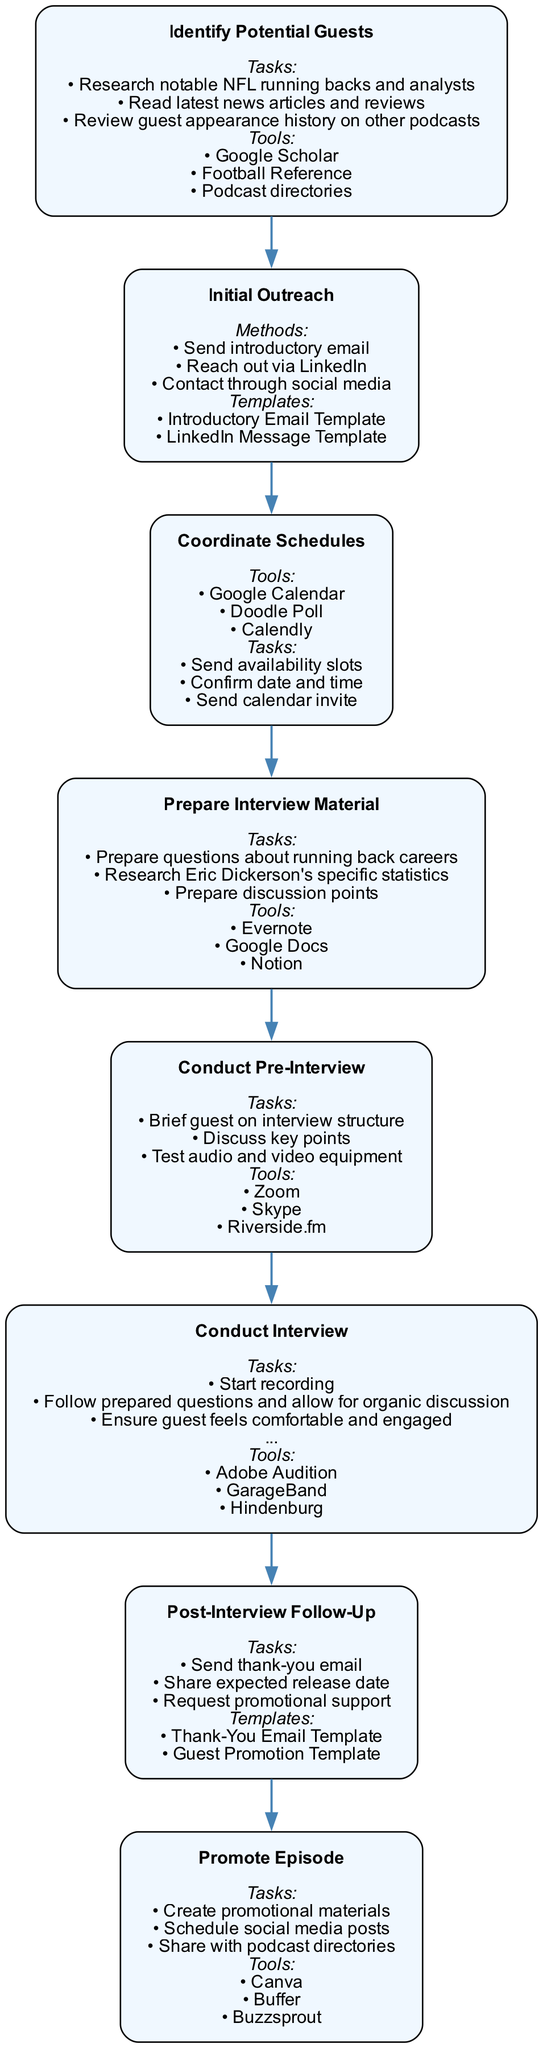What is the first step in the diagram? The diagram starts with the step labeled "Identify Potential Guests," which is the initial stage of the collaboration and scheduling process.
Answer: Identify Potential Guests How many steps are there in total? The diagram consists of eight distinct steps, each representing different parts of the process for collaborating with guest speakers and scheduling interviews.
Answer: Eight What tool is used to coordinate schedules? The diagram lists "Google Calendar," "Doodle Poll," and "Calendly" as tools for coordinating schedules, indicating a variety of options available for scheduling interviews.
Answer: Google Calendar Which step follows "Conduct Pre-Interview"? The step that comes after "Conduct Pre-Interview" in the flow is "Conduct Interview," which implies that after preparing, the actual interview is conducted.
Answer: Conduct Interview What is a task involved in the "Post-Interview Follow-Up" step? A task included in the "Post-Interview Follow-Up" is "Send thank-you email," indicating an essential part of maintaining relationships with guests after the recording process.
Answer: Send thank-you email Which two methods are used for initial outreach? The initial outreach can be done through "Send introductory email" and "Reach out via LinkedIn," showcasing methods of contacting potential guests.
Answer: Send introductory email What are the tools used in "Prepare Interview Material"? In the "Prepare Interview Material" step, the tools mentioned are "Evernote," "Google Docs," and "Notion," emphasizing the digital tools available for preparing content.
Answer: Evernote Which step is focused on promotion? The "Promote Episode" step specifically focuses on promoting the completed podcast episode, indicating its importance in reaching the audience.
Answer: Promote Episode What is the purpose of the "Conduct Pre-Interview"? The purpose of the "Conduct Pre-Interview" is to prepare the guest for the interview by discussing the structure and key points, which ensures a smooth flow during the actual interview.
Answer: Prepare guest for the interview 